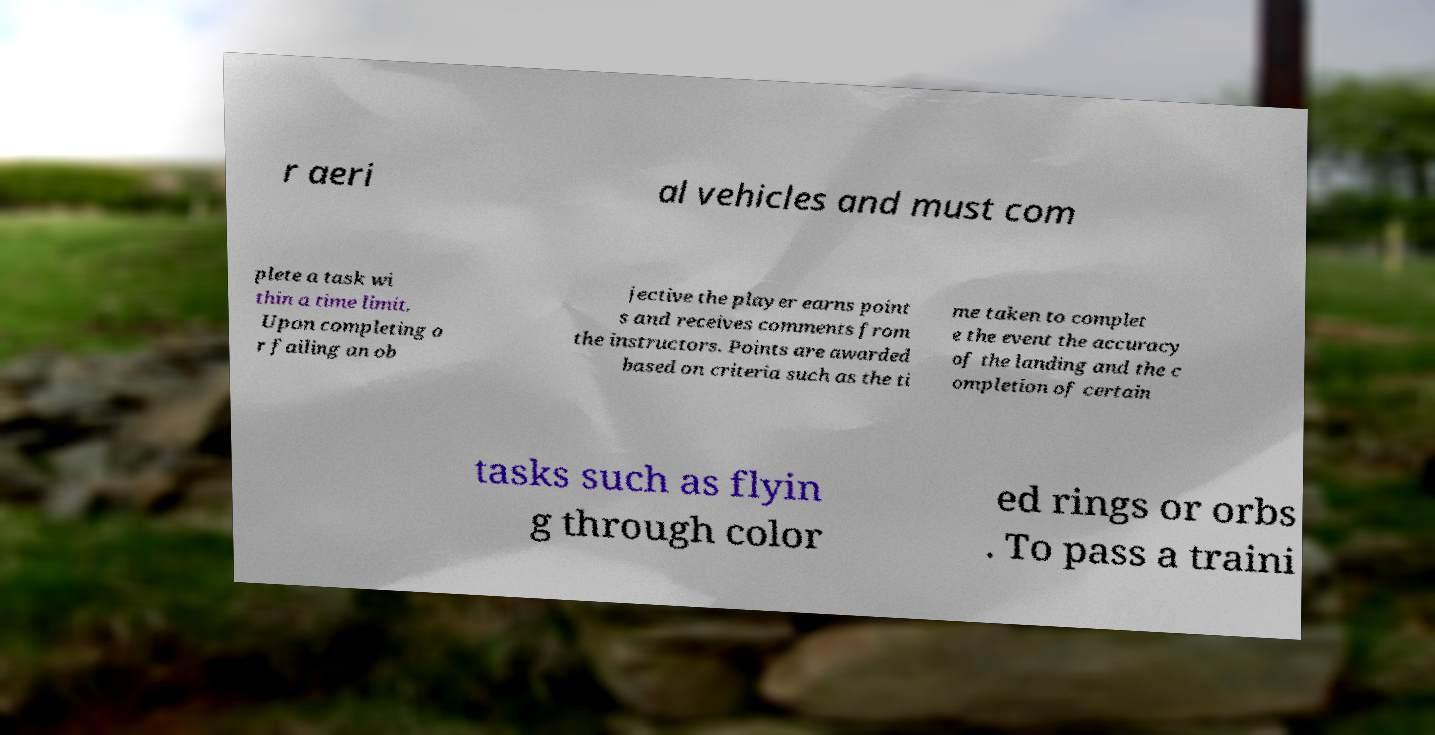I need the written content from this picture converted into text. Can you do that? r aeri al vehicles and must com plete a task wi thin a time limit. Upon completing o r failing an ob jective the player earns point s and receives comments from the instructors. Points are awarded based on criteria such as the ti me taken to complet e the event the accuracy of the landing and the c ompletion of certain tasks such as flyin g through color ed rings or orbs . To pass a traini 